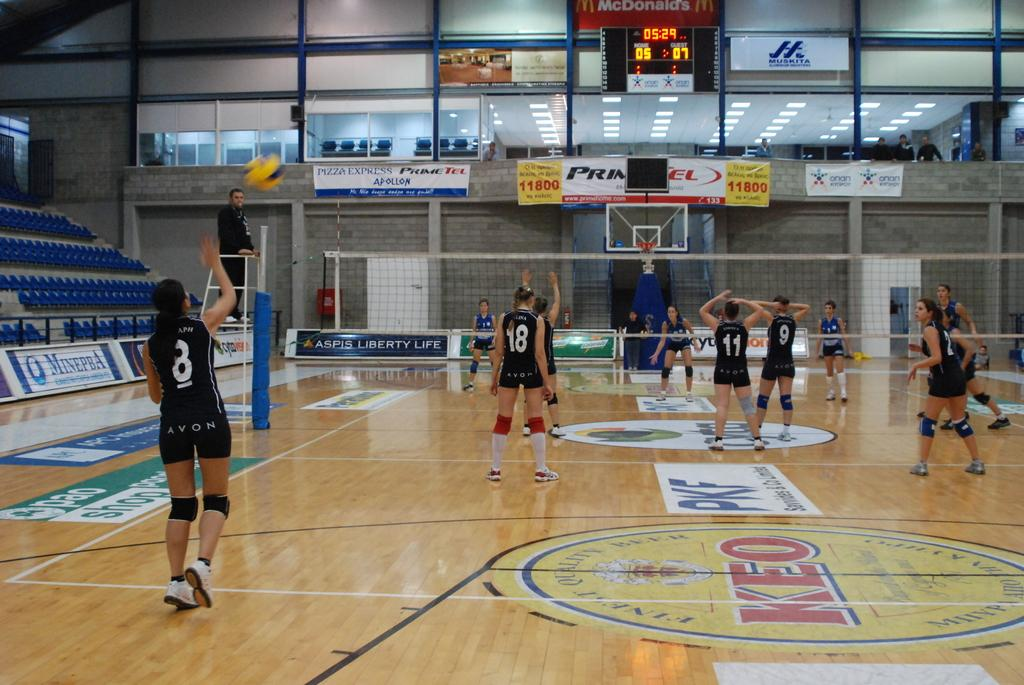<image>
Render a clear and concise summary of the photo. the name Keo that is at the center of a court 